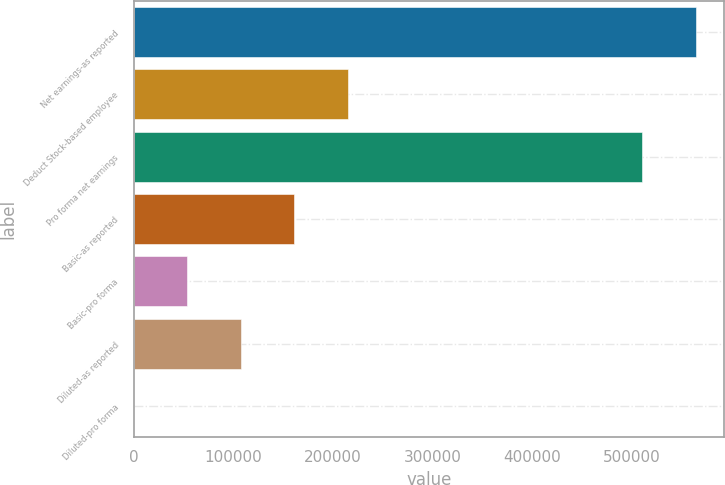<chart> <loc_0><loc_0><loc_500><loc_500><bar_chart><fcel>Net earnings-as reported<fcel>Deduct Stock-based employee<fcel>Pro forma net earnings<fcel>Basic-as reported<fcel>Basic-pro forma<fcel>Diluted-as reported<fcel>Diluted-pro forma<nl><fcel>563762<fcel>214735<fcel>510079<fcel>161051<fcel>53684.8<fcel>107368<fcel>1.6<nl></chart> 